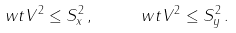<formula> <loc_0><loc_0><loc_500><loc_500>\ w t V ^ { 2 } \leq S _ { x } ^ { 2 } \, , \quad \ w t V ^ { 2 } \leq S _ { y } ^ { 2 } \, .</formula> 